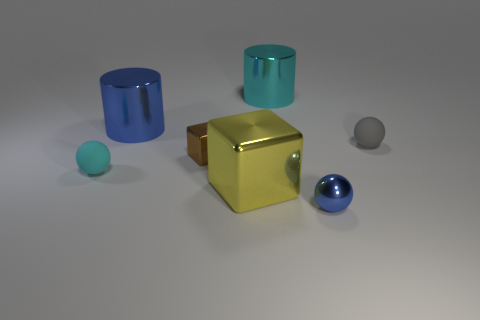How many other objects are the same color as the small cube?
Make the answer very short. 0. There is a matte sphere left of the tiny matte object that is to the right of the big metal cylinder right of the yellow metal object; what is its color?
Keep it short and to the point. Cyan. Are there an equal number of yellow blocks that are left of the large yellow block and large cyan rubber cylinders?
Make the answer very short. Yes. Do the matte ball right of the metal ball and the brown block have the same size?
Offer a terse response. Yes. What number of shiny cylinders are there?
Ensure brevity in your answer.  2. What number of objects are both left of the large yellow thing and in front of the brown metal block?
Give a very brief answer. 1. Are there any other small brown blocks made of the same material as the small brown cube?
Your answer should be compact. No. What material is the cyan object that is to the left of the cyan thing that is behind the cyan matte object made of?
Provide a short and direct response. Rubber. Are there the same number of cyan cylinders on the left side of the small block and blocks to the right of the gray rubber object?
Your response must be concise. Yes. Does the yellow object have the same shape as the big cyan metal object?
Provide a succinct answer. No. 